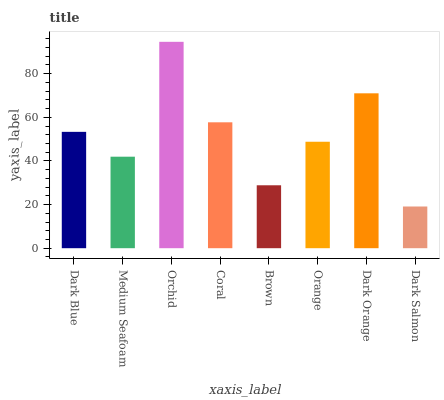Is Medium Seafoam the minimum?
Answer yes or no. No. Is Medium Seafoam the maximum?
Answer yes or no. No. Is Dark Blue greater than Medium Seafoam?
Answer yes or no. Yes. Is Medium Seafoam less than Dark Blue?
Answer yes or no. Yes. Is Medium Seafoam greater than Dark Blue?
Answer yes or no. No. Is Dark Blue less than Medium Seafoam?
Answer yes or no. No. Is Dark Blue the high median?
Answer yes or no. Yes. Is Orange the low median?
Answer yes or no. Yes. Is Medium Seafoam the high median?
Answer yes or no. No. Is Dark Orange the low median?
Answer yes or no. No. 